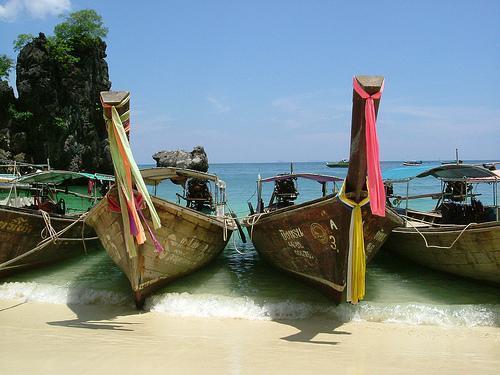How many boats are in this photo?
Give a very brief answer. 4. 